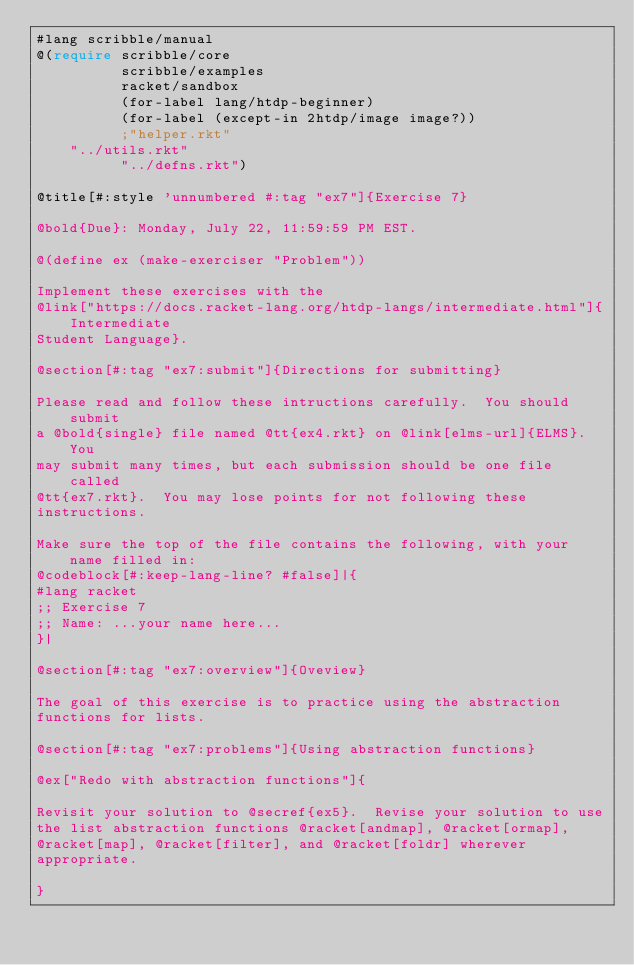Convert code to text. <code><loc_0><loc_0><loc_500><loc_500><_Racket_>#lang scribble/manual
@(require scribble/core 
          scribble/examples
          racket/sandbox
          (for-label lang/htdp-beginner) 
          (for-label (except-in 2htdp/image image?))
          ;"helper.rkt" 
	  "../utils.rkt"
          "../defns.rkt")

@title[#:style 'unnumbered #:tag "ex7"]{Exercise 7}

@bold{Due}: Monday, July 22, 11:59:59 PM EST. 

@(define ex (make-exerciser "Problem"))

Implement these exercises with the
@link["https://docs.racket-lang.org/htdp-langs/intermediate.html"]{Intermediate
Student Language}.

@section[#:tag "ex7:submit"]{Directions for submitting}

Please read and follow these intructions carefully.  You should submit
a @bold{single} file named @tt{ex4.rkt} on @link[elms-url]{ELMS}.  You
may submit many times, but each submission should be one file called
@tt{ex7.rkt}.  You may lose points for not following these
instructions.

Make sure the top of the file contains the following, with your name filled in:
@codeblock[#:keep-lang-line? #false]|{
#lang racket
;; Exercise 7
;; Name: ...your name here...
}|

@section[#:tag "ex7:overview"]{Oveview}

The goal of this exercise is to practice using the abstraction
functions for lists.

@section[#:tag "ex7:problems"]{Using abstraction functions}

@ex["Redo with abstraction functions"]{

Revisit your solution to @secref{ex5}.  Revise your solution to use
the list abstraction functions @racket[andmap], @racket[ormap],
@racket[map], @racket[filter], and @racket[foldr] wherever
appropriate.

}
</code> 